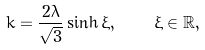Convert formula to latex. <formula><loc_0><loc_0><loc_500><loc_500>k = \frac { 2 \lambda } { \sqrt { 3 } } \sinh \xi , \quad \xi \in \mathbb { R } ,</formula> 